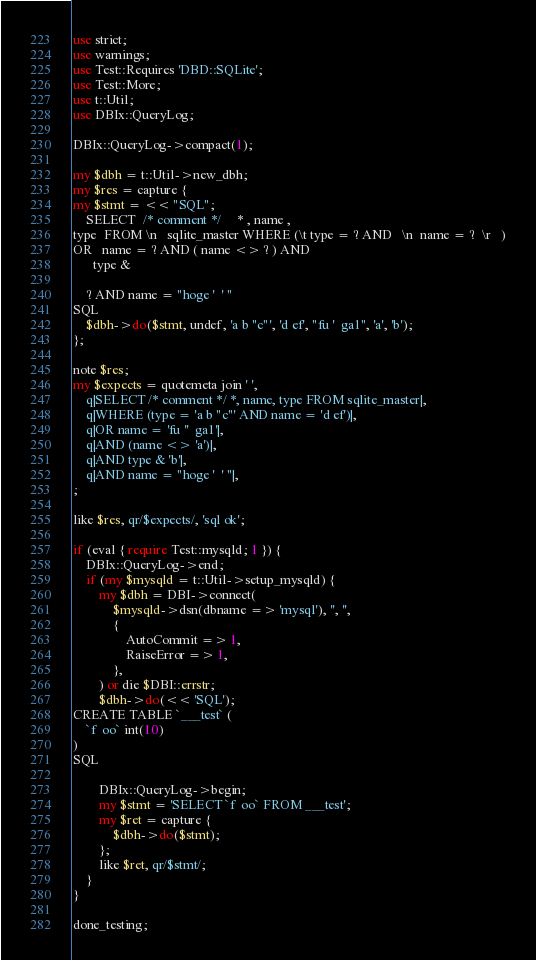Convert code to text. <code><loc_0><loc_0><loc_500><loc_500><_Perl_>use strict;
use warnings;
use Test::Requires 'DBD::SQLite';
use Test::More;
use t::Util;
use DBIx::QueryLog;

DBIx::QueryLog->compact(1);

my $dbh = t::Util->new_dbh;
my $res = capture {
my $stmt = << "SQL";
    SELECT  /* comment */     * , name ,
type  FROM \n   sqlite_master WHERE (\t type = ? AND   \n  name = ?  \r   )
OR   name = ? AND ( name <> ? ) AND
      type &

    ? AND name = "hoge '  ' "
SQL
    $dbh->do($stmt, undef, 'a b "c"', 'd ef', "fu '  ga1", 'a', 'b');
};

note $res;
my $expects = quotemeta join ' ',
    q|SELECT /* comment */ *, name, type FROM sqlite_master|,
    q|WHERE (type = 'a b "c"' AND name = 'd ef')|,
    q|OR name = 'fu ''  ga1'|,
    q|AND (name <> 'a')|,
    q|AND type & 'b'|,
    q|AND name = "hoge '  ' "|,
;

like $res, qr/$expects/, 'sql ok';

if (eval { require Test::mysqld; 1 }) {
    DBIx::QueryLog->end;
    if (my $mysqld = t::Util->setup_mysqld) {
        my $dbh = DBI->connect(
            $mysqld->dsn(dbname => 'mysql'), '', '',
            {
                AutoCommit => 1,
                RaiseError => 1,
            },
        ) or die $DBI::errstr;
        $dbh->do(<< 'SQL');
CREATE TABLE `___test` (
    `f  oo` int(10)
)
SQL

        DBIx::QueryLog->begin;
        my $stmt = 'SELECT `f  oo` FROM ___test';
        my $ret = capture {
            $dbh->do($stmt);
        };
        like $ret, qr/$stmt/;
    }
}

done_testing;
</code> 